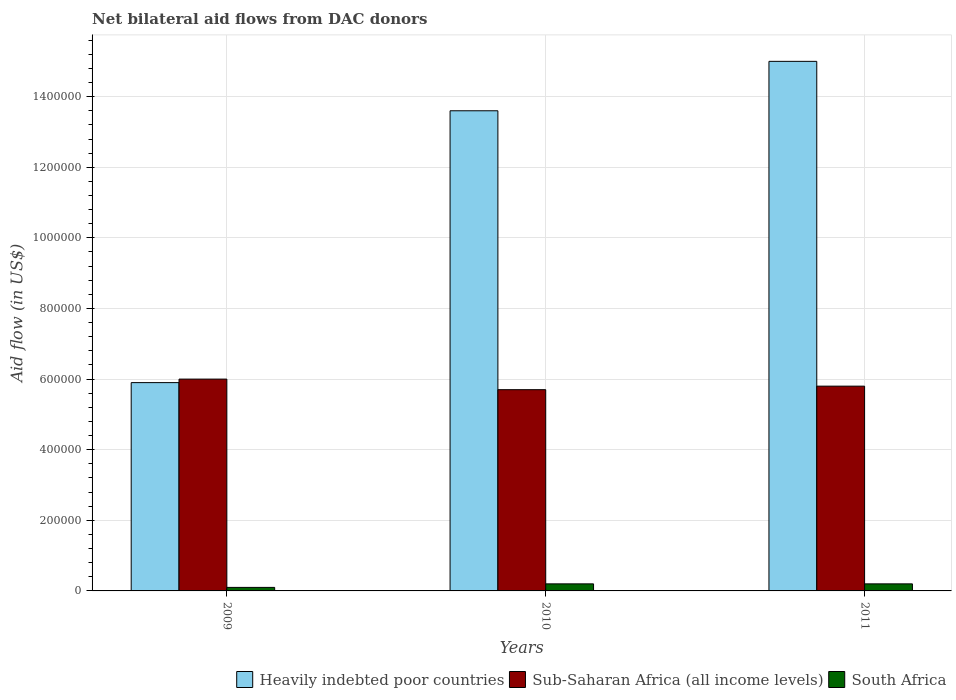How many groups of bars are there?
Your answer should be very brief. 3. What is the label of the 2nd group of bars from the left?
Your answer should be very brief. 2010. What is the net bilateral aid flow in Heavily indebted poor countries in 2009?
Ensure brevity in your answer.  5.90e+05. Across all years, what is the maximum net bilateral aid flow in Sub-Saharan Africa (all income levels)?
Provide a short and direct response. 6.00e+05. In which year was the net bilateral aid flow in Heavily indebted poor countries minimum?
Provide a short and direct response. 2009. What is the total net bilateral aid flow in Sub-Saharan Africa (all income levels) in the graph?
Your answer should be very brief. 1.75e+06. What is the difference between the net bilateral aid flow in Heavily indebted poor countries in 2011 and the net bilateral aid flow in South Africa in 2010?
Your response must be concise. 1.48e+06. What is the average net bilateral aid flow in South Africa per year?
Your response must be concise. 1.67e+04. In the year 2009, what is the difference between the net bilateral aid flow in Heavily indebted poor countries and net bilateral aid flow in South Africa?
Your answer should be compact. 5.80e+05. What is the ratio of the net bilateral aid flow in Sub-Saharan Africa (all income levels) in 2009 to that in 2011?
Make the answer very short. 1.03. Is the net bilateral aid flow in Heavily indebted poor countries in 2009 less than that in 2011?
Your answer should be compact. Yes. Is the difference between the net bilateral aid flow in Heavily indebted poor countries in 2009 and 2011 greater than the difference between the net bilateral aid flow in South Africa in 2009 and 2011?
Your answer should be very brief. No. What is the difference between the highest and the lowest net bilateral aid flow in Heavily indebted poor countries?
Your response must be concise. 9.10e+05. Is the sum of the net bilateral aid flow in South Africa in 2010 and 2011 greater than the maximum net bilateral aid flow in Heavily indebted poor countries across all years?
Provide a succinct answer. No. What does the 2nd bar from the left in 2009 represents?
Your answer should be very brief. Sub-Saharan Africa (all income levels). What does the 2nd bar from the right in 2009 represents?
Keep it short and to the point. Sub-Saharan Africa (all income levels). Is it the case that in every year, the sum of the net bilateral aid flow in South Africa and net bilateral aid flow in Heavily indebted poor countries is greater than the net bilateral aid flow in Sub-Saharan Africa (all income levels)?
Offer a very short reply. No. How many bars are there?
Ensure brevity in your answer.  9. Are all the bars in the graph horizontal?
Your answer should be compact. No. How many years are there in the graph?
Your answer should be compact. 3. What is the difference between two consecutive major ticks on the Y-axis?
Offer a terse response. 2.00e+05. Are the values on the major ticks of Y-axis written in scientific E-notation?
Give a very brief answer. No. Where does the legend appear in the graph?
Your answer should be very brief. Bottom right. How are the legend labels stacked?
Give a very brief answer. Horizontal. What is the title of the graph?
Offer a very short reply. Net bilateral aid flows from DAC donors. What is the label or title of the Y-axis?
Your answer should be very brief. Aid flow (in US$). What is the Aid flow (in US$) of Heavily indebted poor countries in 2009?
Ensure brevity in your answer.  5.90e+05. What is the Aid flow (in US$) of Heavily indebted poor countries in 2010?
Your answer should be compact. 1.36e+06. What is the Aid flow (in US$) of Sub-Saharan Africa (all income levels) in 2010?
Provide a short and direct response. 5.70e+05. What is the Aid flow (in US$) of Heavily indebted poor countries in 2011?
Your response must be concise. 1.50e+06. What is the Aid flow (in US$) of Sub-Saharan Africa (all income levels) in 2011?
Provide a short and direct response. 5.80e+05. Across all years, what is the maximum Aid flow (in US$) of Heavily indebted poor countries?
Provide a succinct answer. 1.50e+06. Across all years, what is the maximum Aid flow (in US$) in Sub-Saharan Africa (all income levels)?
Ensure brevity in your answer.  6.00e+05. Across all years, what is the minimum Aid flow (in US$) of Heavily indebted poor countries?
Ensure brevity in your answer.  5.90e+05. Across all years, what is the minimum Aid flow (in US$) of Sub-Saharan Africa (all income levels)?
Your response must be concise. 5.70e+05. Across all years, what is the minimum Aid flow (in US$) of South Africa?
Offer a very short reply. 10000. What is the total Aid flow (in US$) in Heavily indebted poor countries in the graph?
Ensure brevity in your answer.  3.45e+06. What is the total Aid flow (in US$) of Sub-Saharan Africa (all income levels) in the graph?
Your answer should be compact. 1.75e+06. What is the total Aid flow (in US$) of South Africa in the graph?
Your answer should be compact. 5.00e+04. What is the difference between the Aid flow (in US$) of Heavily indebted poor countries in 2009 and that in 2010?
Offer a terse response. -7.70e+05. What is the difference between the Aid flow (in US$) of South Africa in 2009 and that in 2010?
Ensure brevity in your answer.  -10000. What is the difference between the Aid flow (in US$) in Heavily indebted poor countries in 2009 and that in 2011?
Provide a short and direct response. -9.10e+05. What is the difference between the Aid flow (in US$) of Sub-Saharan Africa (all income levels) in 2009 and that in 2011?
Offer a terse response. 2.00e+04. What is the difference between the Aid flow (in US$) of South Africa in 2009 and that in 2011?
Your answer should be very brief. -10000. What is the difference between the Aid flow (in US$) in Heavily indebted poor countries in 2010 and that in 2011?
Give a very brief answer. -1.40e+05. What is the difference between the Aid flow (in US$) of Sub-Saharan Africa (all income levels) in 2010 and that in 2011?
Your answer should be compact. -10000. What is the difference between the Aid flow (in US$) in South Africa in 2010 and that in 2011?
Give a very brief answer. 0. What is the difference between the Aid flow (in US$) of Heavily indebted poor countries in 2009 and the Aid flow (in US$) of South Africa in 2010?
Ensure brevity in your answer.  5.70e+05. What is the difference between the Aid flow (in US$) of Sub-Saharan Africa (all income levels) in 2009 and the Aid flow (in US$) of South Africa in 2010?
Your answer should be very brief. 5.80e+05. What is the difference between the Aid flow (in US$) in Heavily indebted poor countries in 2009 and the Aid flow (in US$) in South Africa in 2011?
Your answer should be compact. 5.70e+05. What is the difference between the Aid flow (in US$) in Sub-Saharan Africa (all income levels) in 2009 and the Aid flow (in US$) in South Africa in 2011?
Provide a short and direct response. 5.80e+05. What is the difference between the Aid flow (in US$) of Heavily indebted poor countries in 2010 and the Aid flow (in US$) of Sub-Saharan Africa (all income levels) in 2011?
Ensure brevity in your answer.  7.80e+05. What is the difference between the Aid flow (in US$) in Heavily indebted poor countries in 2010 and the Aid flow (in US$) in South Africa in 2011?
Your answer should be very brief. 1.34e+06. What is the difference between the Aid flow (in US$) of Sub-Saharan Africa (all income levels) in 2010 and the Aid flow (in US$) of South Africa in 2011?
Provide a succinct answer. 5.50e+05. What is the average Aid flow (in US$) of Heavily indebted poor countries per year?
Make the answer very short. 1.15e+06. What is the average Aid flow (in US$) of Sub-Saharan Africa (all income levels) per year?
Your response must be concise. 5.83e+05. What is the average Aid flow (in US$) of South Africa per year?
Make the answer very short. 1.67e+04. In the year 2009, what is the difference between the Aid flow (in US$) in Heavily indebted poor countries and Aid flow (in US$) in South Africa?
Your answer should be compact. 5.80e+05. In the year 2009, what is the difference between the Aid flow (in US$) of Sub-Saharan Africa (all income levels) and Aid flow (in US$) of South Africa?
Keep it short and to the point. 5.90e+05. In the year 2010, what is the difference between the Aid flow (in US$) of Heavily indebted poor countries and Aid flow (in US$) of Sub-Saharan Africa (all income levels)?
Offer a very short reply. 7.90e+05. In the year 2010, what is the difference between the Aid flow (in US$) of Heavily indebted poor countries and Aid flow (in US$) of South Africa?
Your answer should be very brief. 1.34e+06. In the year 2010, what is the difference between the Aid flow (in US$) in Sub-Saharan Africa (all income levels) and Aid flow (in US$) in South Africa?
Your answer should be very brief. 5.50e+05. In the year 2011, what is the difference between the Aid flow (in US$) in Heavily indebted poor countries and Aid flow (in US$) in Sub-Saharan Africa (all income levels)?
Offer a very short reply. 9.20e+05. In the year 2011, what is the difference between the Aid flow (in US$) of Heavily indebted poor countries and Aid flow (in US$) of South Africa?
Offer a very short reply. 1.48e+06. In the year 2011, what is the difference between the Aid flow (in US$) of Sub-Saharan Africa (all income levels) and Aid flow (in US$) of South Africa?
Ensure brevity in your answer.  5.60e+05. What is the ratio of the Aid flow (in US$) in Heavily indebted poor countries in 2009 to that in 2010?
Offer a terse response. 0.43. What is the ratio of the Aid flow (in US$) of Sub-Saharan Africa (all income levels) in 2009 to that in 2010?
Your answer should be very brief. 1.05. What is the ratio of the Aid flow (in US$) of Heavily indebted poor countries in 2009 to that in 2011?
Ensure brevity in your answer.  0.39. What is the ratio of the Aid flow (in US$) of Sub-Saharan Africa (all income levels) in 2009 to that in 2011?
Offer a very short reply. 1.03. What is the ratio of the Aid flow (in US$) in Heavily indebted poor countries in 2010 to that in 2011?
Provide a short and direct response. 0.91. What is the ratio of the Aid flow (in US$) in Sub-Saharan Africa (all income levels) in 2010 to that in 2011?
Keep it short and to the point. 0.98. What is the difference between the highest and the second highest Aid flow (in US$) of Heavily indebted poor countries?
Make the answer very short. 1.40e+05. What is the difference between the highest and the lowest Aid flow (in US$) in Heavily indebted poor countries?
Provide a short and direct response. 9.10e+05. What is the difference between the highest and the lowest Aid flow (in US$) of Sub-Saharan Africa (all income levels)?
Make the answer very short. 3.00e+04. What is the difference between the highest and the lowest Aid flow (in US$) of South Africa?
Make the answer very short. 10000. 